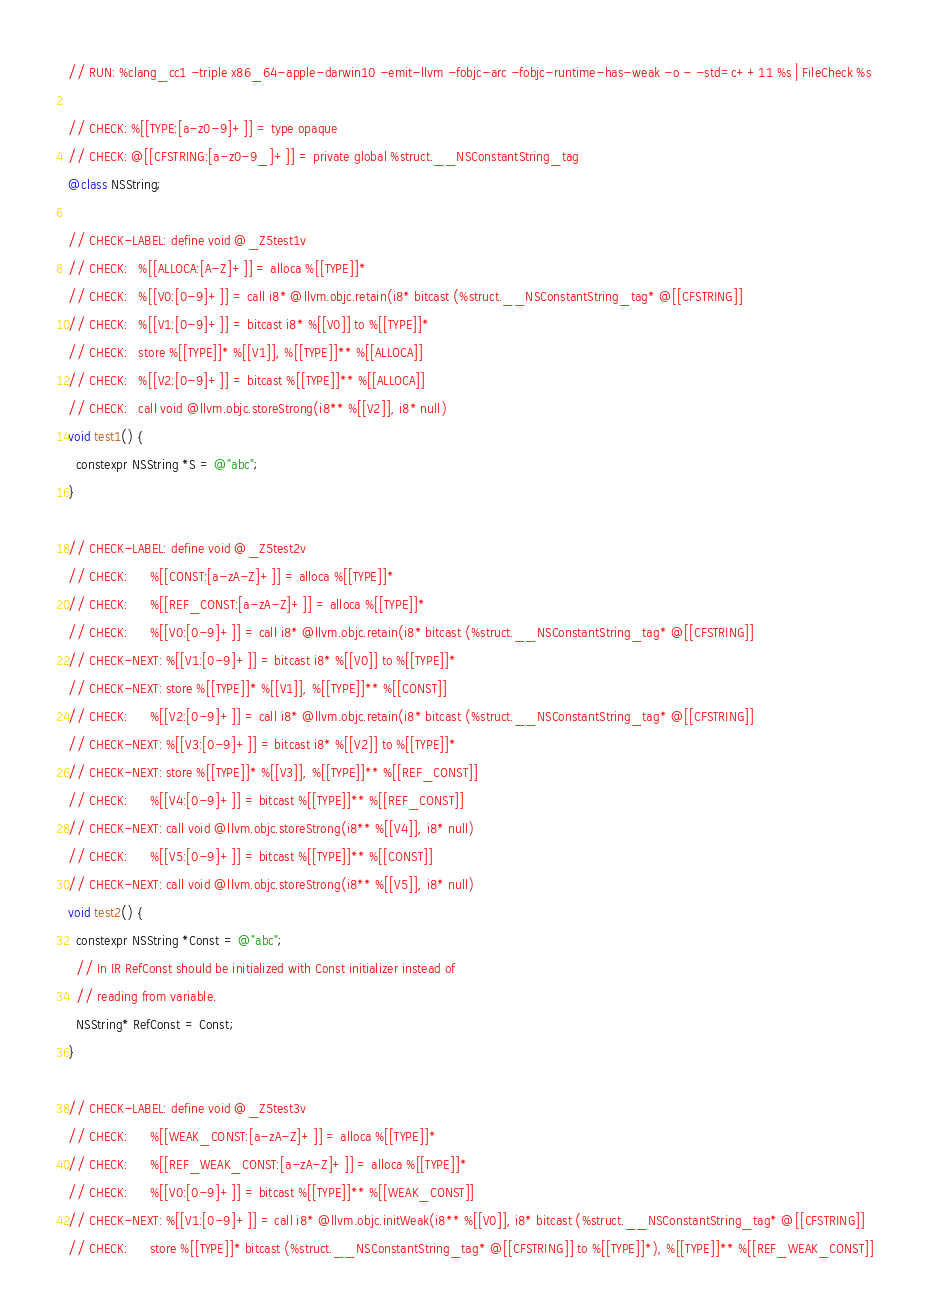<code> <loc_0><loc_0><loc_500><loc_500><_ObjectiveC_>// RUN: %clang_cc1 -triple x86_64-apple-darwin10 -emit-llvm -fobjc-arc -fobjc-runtime-has-weak -o - -std=c++11 %s | FileCheck %s

// CHECK: %[[TYPE:[a-z0-9]+]] = type opaque
// CHECK: @[[CFSTRING:[a-z0-9_]+]] = private global %struct.__NSConstantString_tag
@class NSString;

// CHECK-LABEL: define void @_Z5test1v
// CHECK:   %[[ALLOCA:[A-Z]+]] = alloca %[[TYPE]]*
// CHECK:   %[[V0:[0-9]+]] = call i8* @llvm.objc.retain(i8* bitcast (%struct.__NSConstantString_tag* @[[CFSTRING]]
// CHECK:   %[[V1:[0-9]+]] = bitcast i8* %[[V0]] to %[[TYPE]]*
// CHECK:   store %[[TYPE]]* %[[V1]], %[[TYPE]]** %[[ALLOCA]]
// CHECK:   %[[V2:[0-9]+]] = bitcast %[[TYPE]]** %[[ALLOCA]]
// CHECK:   call void @llvm.objc.storeStrong(i8** %[[V2]], i8* null)
void test1() {
  constexpr NSString *S = @"abc";
}

// CHECK-LABEL: define void @_Z5test2v
// CHECK:      %[[CONST:[a-zA-Z]+]] = alloca %[[TYPE]]*
// CHECK:      %[[REF_CONST:[a-zA-Z]+]] = alloca %[[TYPE]]*
// CHECK:      %[[V0:[0-9]+]] = call i8* @llvm.objc.retain(i8* bitcast (%struct.__NSConstantString_tag* @[[CFSTRING]]
// CHECK-NEXT: %[[V1:[0-9]+]] = bitcast i8* %[[V0]] to %[[TYPE]]*
// CHECK-NEXT: store %[[TYPE]]* %[[V1]], %[[TYPE]]** %[[CONST]]
// CHECK:      %[[V2:[0-9]+]] = call i8* @llvm.objc.retain(i8* bitcast (%struct.__NSConstantString_tag* @[[CFSTRING]]
// CHECK-NEXT: %[[V3:[0-9]+]] = bitcast i8* %[[V2]] to %[[TYPE]]*
// CHECK-NEXT: store %[[TYPE]]* %[[V3]], %[[TYPE]]** %[[REF_CONST]]
// CHECK:      %[[V4:[0-9]+]] = bitcast %[[TYPE]]** %[[REF_CONST]]
// CHECK-NEXT: call void @llvm.objc.storeStrong(i8** %[[V4]], i8* null)
// CHECK:      %[[V5:[0-9]+]] = bitcast %[[TYPE]]** %[[CONST]]
// CHECK-NEXT: call void @llvm.objc.storeStrong(i8** %[[V5]], i8* null)
void test2() {
  constexpr NSString *Const = @"abc";
  // In IR RefConst should be initialized with Const initializer instead of
  // reading from variable.
  NSString* RefConst = Const;
}

// CHECK-LABEL: define void @_Z5test3v
// CHECK:      %[[WEAK_CONST:[a-zA-Z]+]] = alloca %[[TYPE]]*
// CHECK:      %[[REF_WEAK_CONST:[a-zA-Z]+]] = alloca %[[TYPE]]*
// CHECK:      %[[V0:[0-9]+]] = bitcast %[[TYPE]]** %[[WEAK_CONST]]
// CHECK-NEXT: %[[V1:[0-9]+]] = call i8* @llvm.objc.initWeak(i8** %[[V0]], i8* bitcast (%struct.__NSConstantString_tag* @[[CFSTRING]]
// CHECK:      store %[[TYPE]]* bitcast (%struct.__NSConstantString_tag* @[[CFSTRING]] to %[[TYPE]]*), %[[TYPE]]** %[[REF_WEAK_CONST]]</code> 